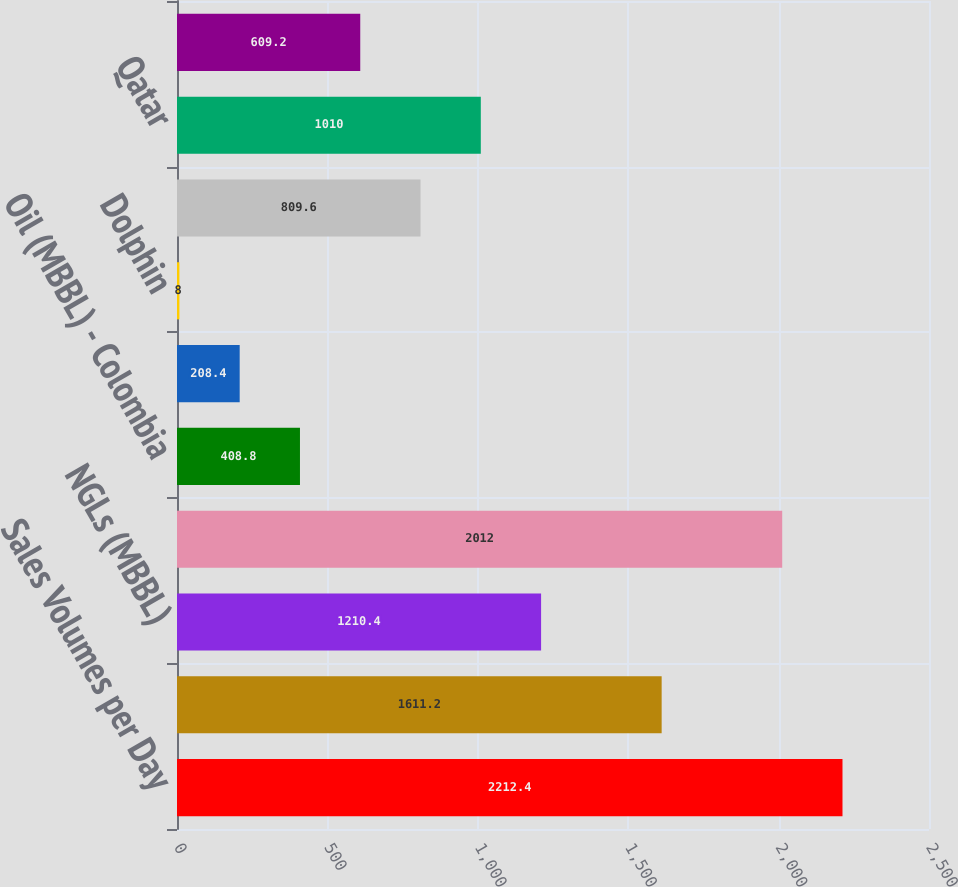Convert chart. <chart><loc_0><loc_0><loc_500><loc_500><bar_chart><fcel>Sales Volumes per Day<fcel>Oil (MBBL)<fcel>NGLs (MBBL)<fcel>Natural gas (MMCF)<fcel>Oil (MBBL) - Colombia<fcel>Natural gas (MMCF) - Bolivia<fcel>Dolphin<fcel>Oman<fcel>Qatar<fcel>Other<nl><fcel>2212.4<fcel>1611.2<fcel>1210.4<fcel>2012<fcel>408.8<fcel>208.4<fcel>8<fcel>809.6<fcel>1010<fcel>609.2<nl></chart> 